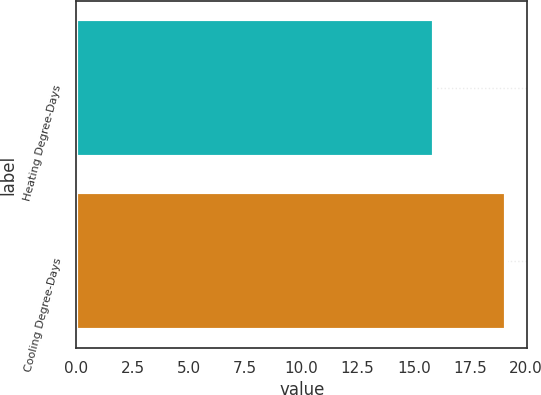Convert chart. <chart><loc_0><loc_0><loc_500><loc_500><bar_chart><fcel>Heating Degree-Days<fcel>Cooling Degree-Days<nl><fcel>15.9<fcel>19.1<nl></chart> 